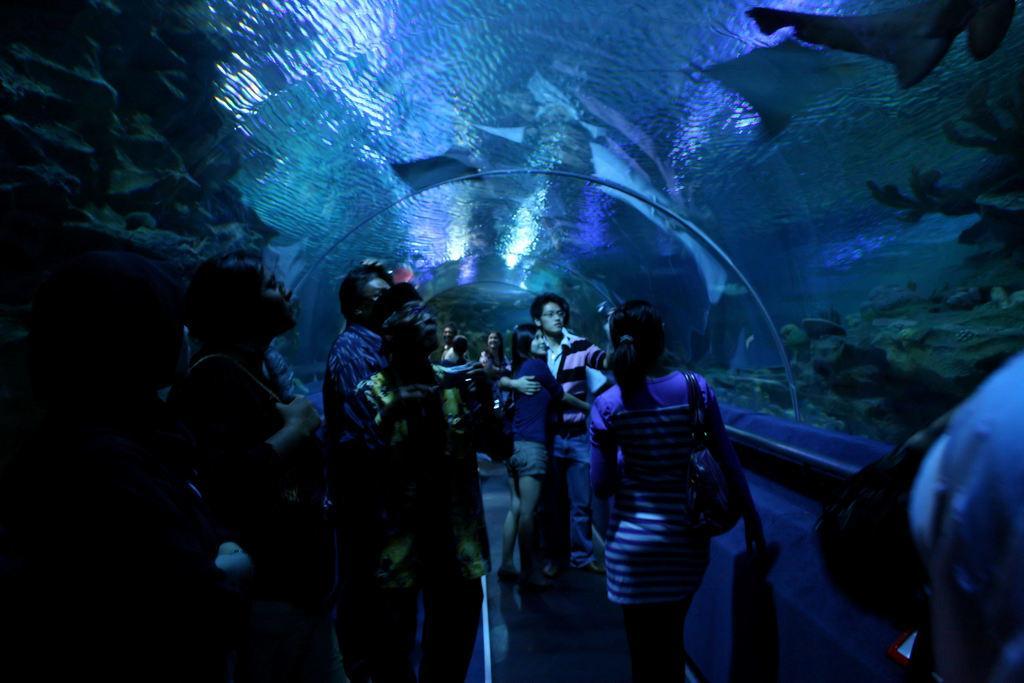Could you give a brief overview of what you see in this image? In this picture I can see there is a aquarium tunnel and there is water, there are few fishes, rocks into left and right. There are few people standing here in the tunnel, to right side there is a person, there is a woman standing next to him and she is holding a bag and she has a handbag. There are few more people standing here and they are holding camera. There is water in the aquarium. 